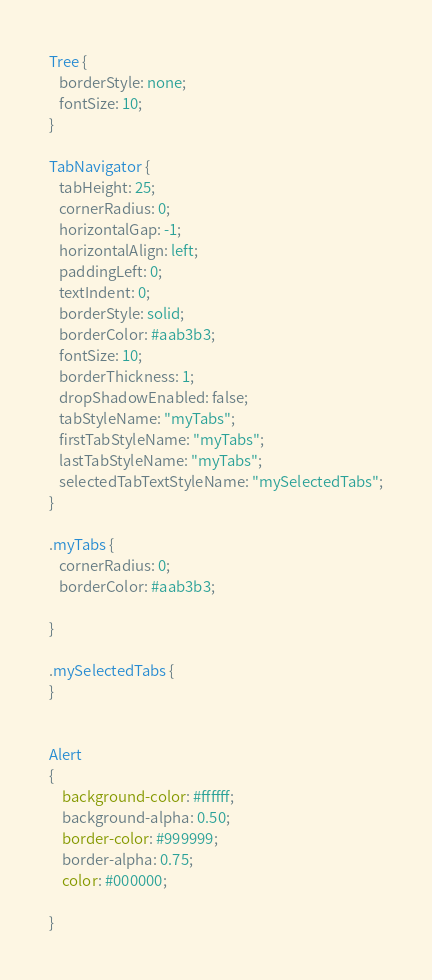<code> <loc_0><loc_0><loc_500><loc_500><_CSS_>Tree {
   borderStyle: none;
   fontSize: 10;
}

TabNavigator {
   tabHeight: 25;
   cornerRadius: 0;
   horizontalGap: -1;
   horizontalAlign: left;
   paddingLeft: 0;
   textIndent: 0;
   borderStyle: solid;
   borderColor: #aab3b3;
   fontSize: 10;
   borderThickness: 1;
   dropShadowEnabled: false;
   tabStyleName: "myTabs";
   firstTabStyleName: "myTabs";
   lastTabStyleName: "myTabs";
   selectedTabTextStyleName: "mySelectedTabs";
}

.myTabs {
   cornerRadius: 0;
   borderColor: #aab3b3;

}

.mySelectedTabs {
}


Alert
{
	background-color: #ffffff;
	background-alpha: 0.50;
	border-color: #999999;
	border-alpha: 0.75;
	color: #000000;
	
}</code> 